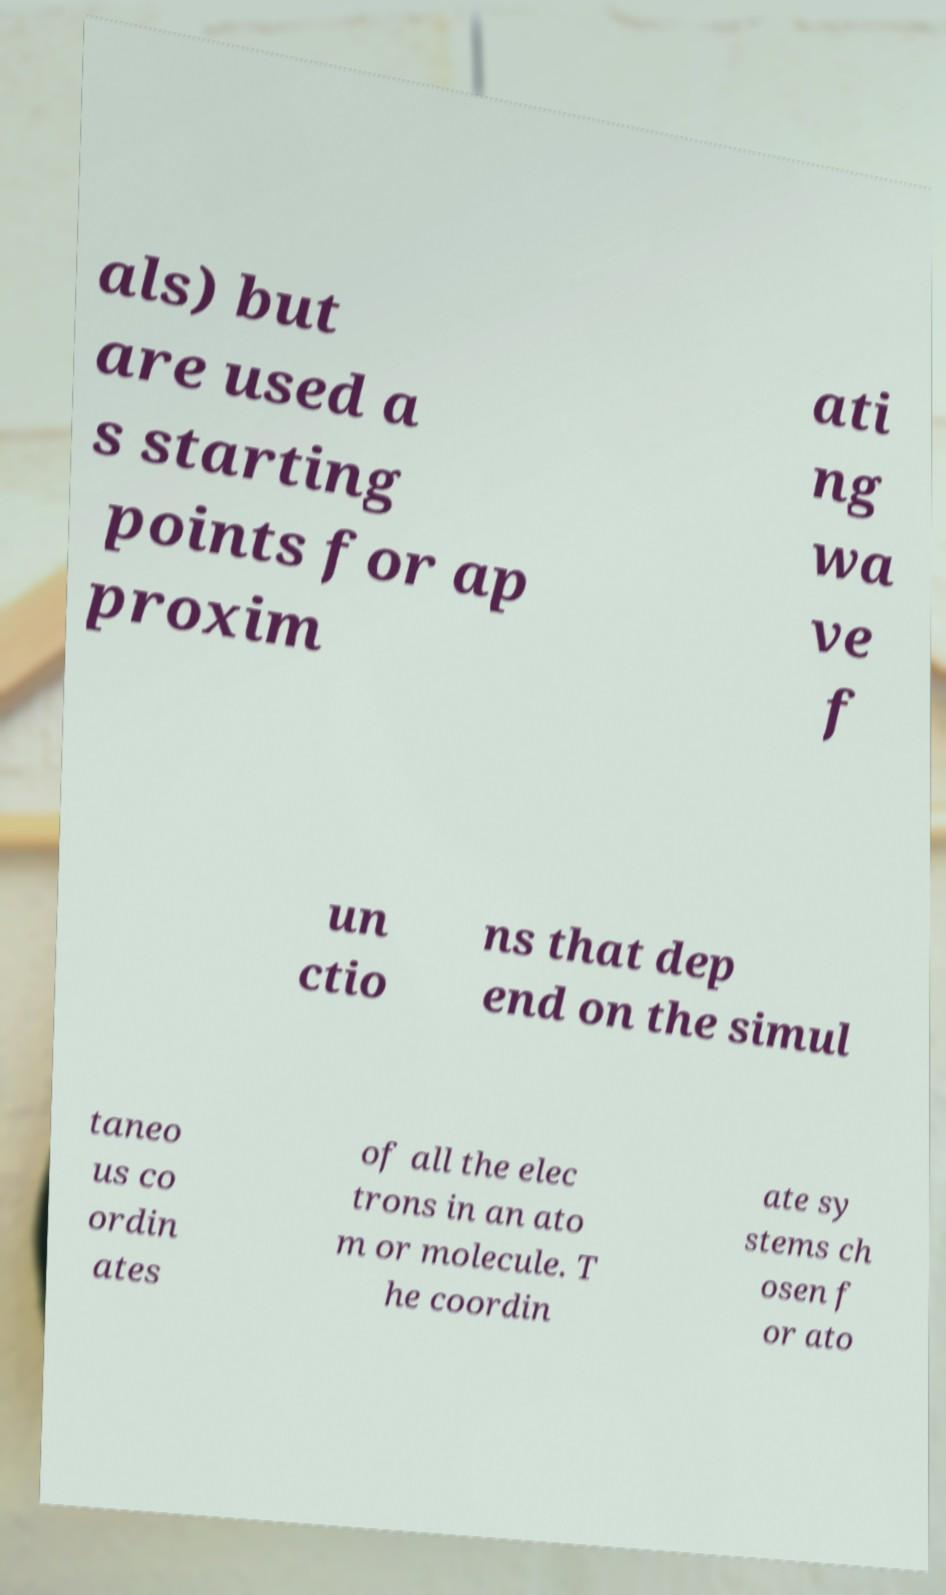Please read and relay the text visible in this image. What does it say? als) but are used a s starting points for ap proxim ati ng wa ve f un ctio ns that dep end on the simul taneo us co ordin ates of all the elec trons in an ato m or molecule. T he coordin ate sy stems ch osen f or ato 